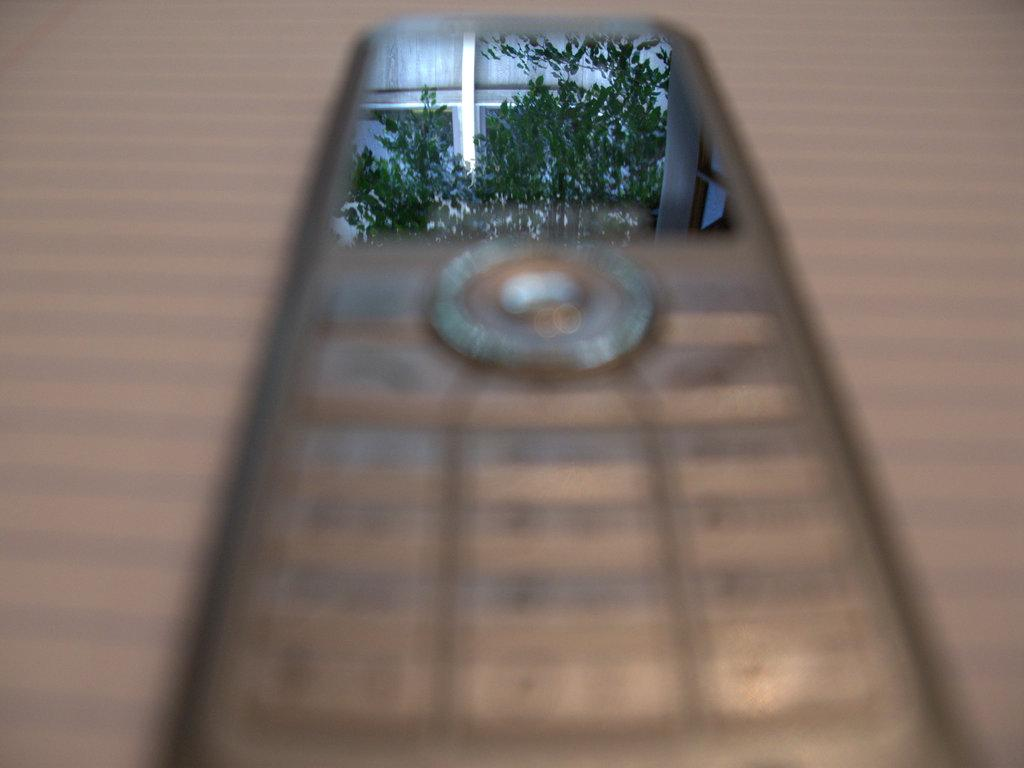What electronic device is present in the image? There is a mobile phone in the image. Where is the mobile phone located? The mobile phone is on a surface. What type of car is parked next to the mobile phone in the image? There is no car present in the image; it only features a mobile phone on a surface. 